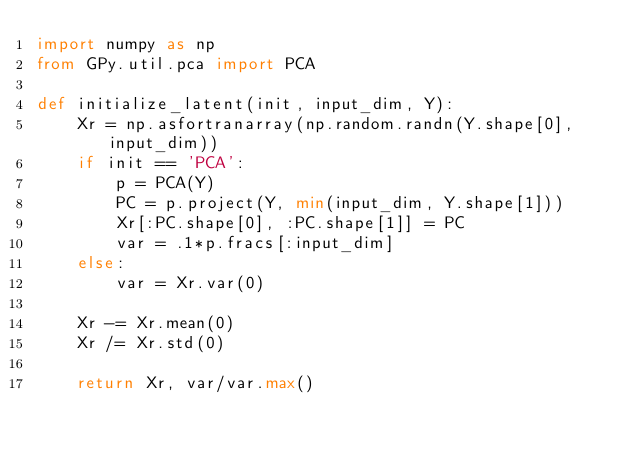<code> <loc_0><loc_0><loc_500><loc_500><_Python_>import numpy as np
from GPy.util.pca import PCA

def initialize_latent(init, input_dim, Y):
    Xr = np.asfortranarray(np.random.randn(Y.shape[0], input_dim))
    if init == 'PCA':
        p = PCA(Y)
        PC = p.project(Y, min(input_dim, Y.shape[1]))
        Xr[:PC.shape[0], :PC.shape[1]] = PC
        var = .1*p.fracs[:input_dim]
    else:
        var = Xr.var(0)

    Xr -= Xr.mean(0)
    Xr /= Xr.std(0)

    return Xr, var/var.max()
</code> 